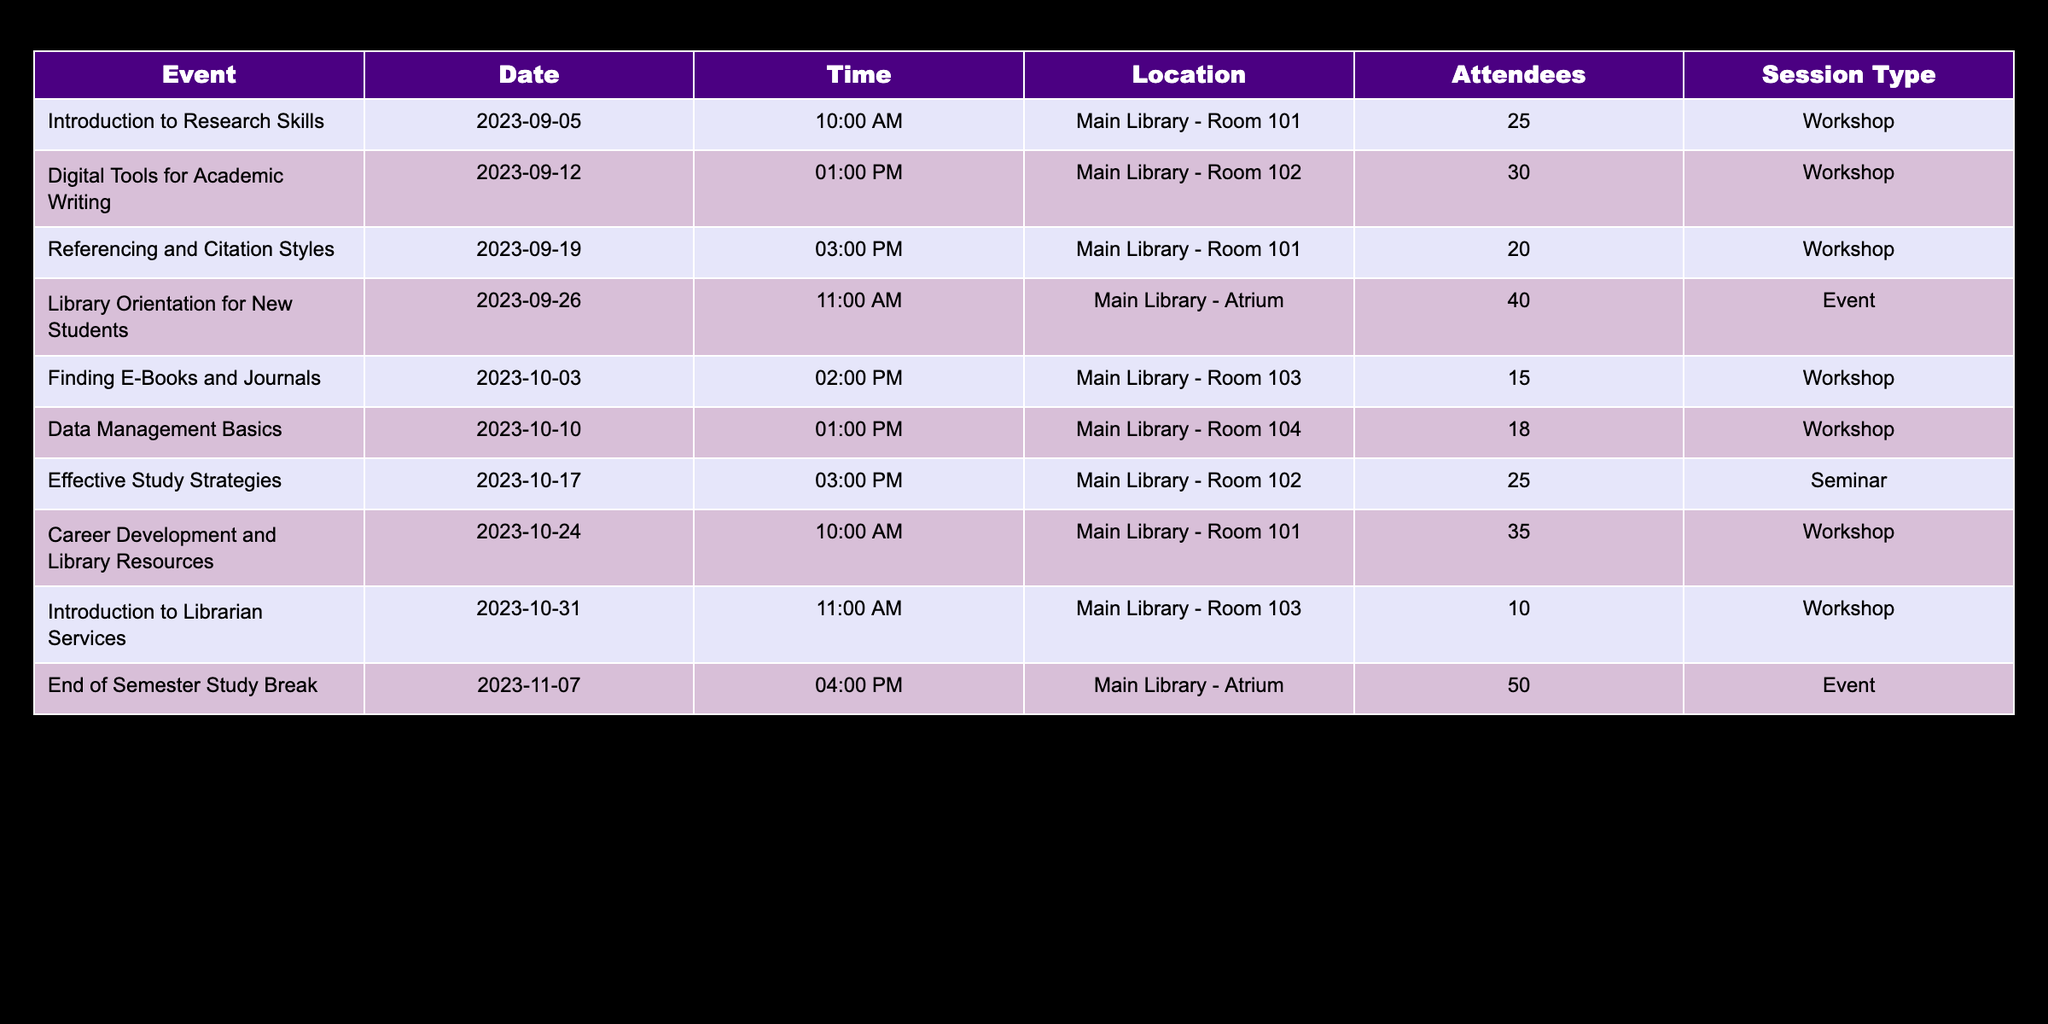What was the total number of attendees for all workshops? To find the total number of attendees for all workshops, I will sum the number of attendees from the relevant rows in the table. The attendees for the workshops are: 25, 30, 20, 15, 18, 25, 35, and 10. Adding these gives 25 + 30 + 20 + 15 + 18 + 25 + 35 + 10 = 178.
Answer: 178 Which workshop had the highest attendance? I will compare the number of attendees for each workshop. The attendees are: 25 (Introduction to Research Skills), 30 (Digital Tools for Academic Writing), 20 (Referencing and Citation Styles), 15 (Finding E-Books and Journals), 18 (Data Management Basics), 25 (Effective Study Strategies), 35 (Career Development and Library Resources), and 10 (Introduction to Librarian Services). The highest number is 35 from the Career Development and Library Resources workshop.
Answer: Career Development and Library Resources Was the attendance for the End of Semester Study Break event more than 40? The attendance for the End of Semester Study Break event is listed as 50. Since 50 is greater than 40, the answer to the question is affirmative.
Answer: Yes What was the average attendance at all the library events? I will first identify the events in the table: Library Orientation for New Students (40), End of Semester Study Break (50). The total attendance for these two events is 40 + 50 = 90, and there are 2 events. To find the average attendance, I divide the total by the number of events: 90 / 2 = 45.
Answer: 45 How many workshops had fewer than 20 attendees? I will look through the table for workshops and check their attendee numbers. The workshops are: Introduction to Research Skills (25), Digital Tools for Academic Writing (30), Referencing and Citation Styles (20), Finding E-Books and Journals (15), Data Management Basics (18), Effective Study Strategies (25), Career Development and Library Resources (35), Introduction to Librarian Services (10). The workshops with fewer than 20 attendees are Finding E-Books and Journals (15) and Introduction to Librarian Services (10), giving a total of 2 workshops.
Answer: 2 Which event had the least number of attendees? I will compare the attendance numbers of each event. The events are Library Orientation for New Students (40) and End of Semester Study Break (50). The least number of attendees is 40 from the Library Orientation for New Students.
Answer: Library Orientation for New Students 